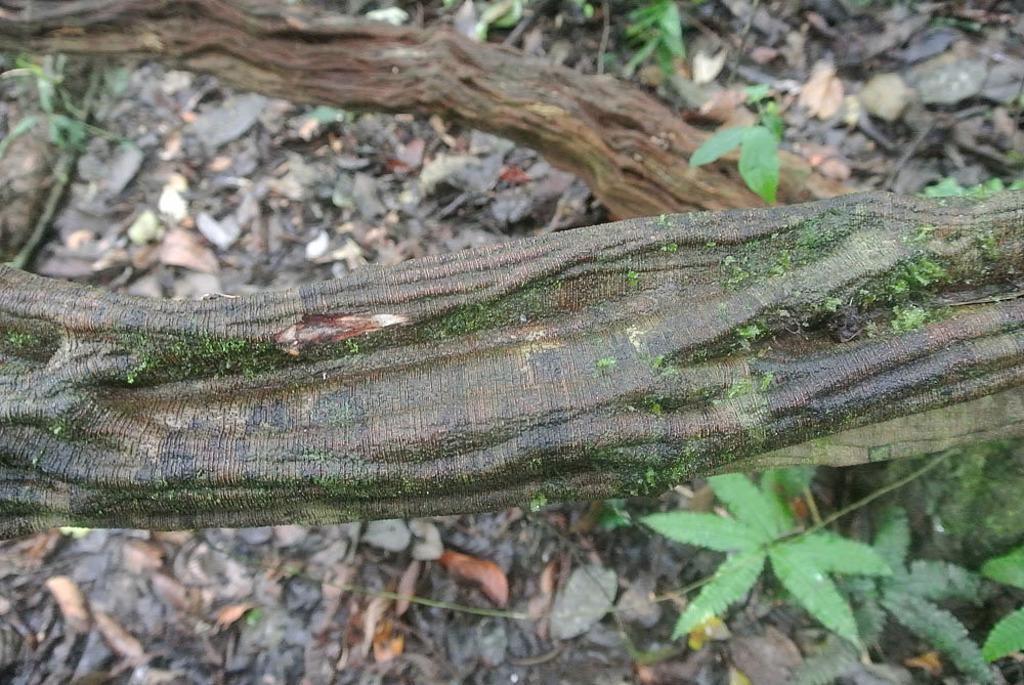Describe this image in one or two sentences. In the image we can see some stems and plants and leaves. 